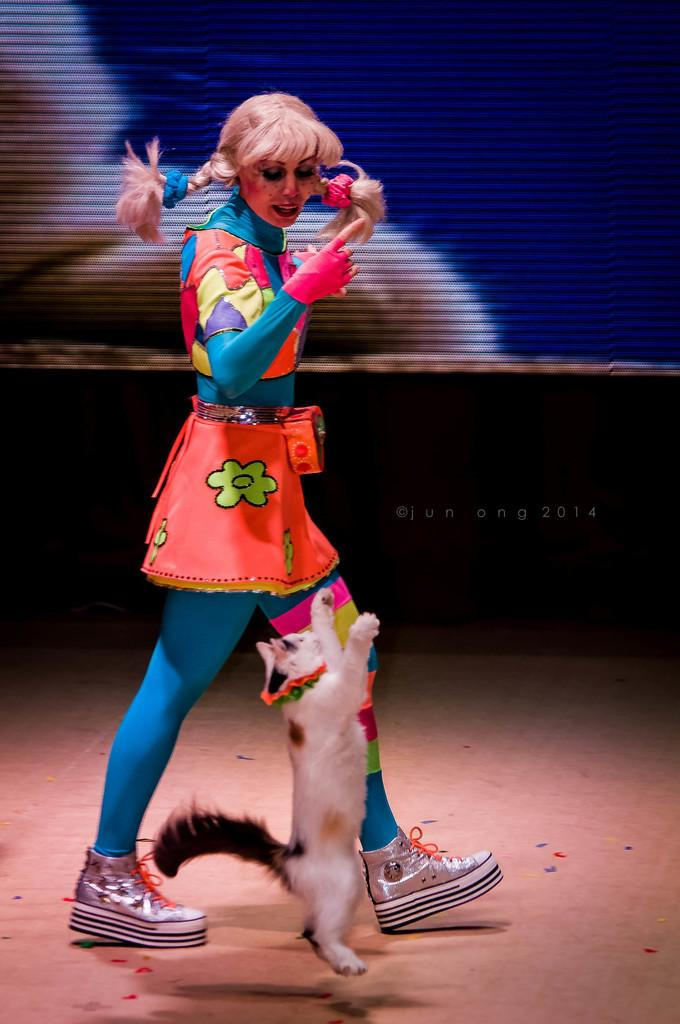Who or what is present in the image? There is a person and a cat in the image. What else can be seen in the image besides the person and the cat? There is a watermark and some text in the image. Can you describe the watermark in the image? Unfortunately, the details of the watermark cannot be determined from the provided facts. What is the purpose of the text in the image? The purpose of the text in the image is not specified in the provided facts. What type of van is visible in the image? There is no van present in the image. What game is the person playing with the cat in the image? There is no game being played in the image; it only shows a person and a cat. 